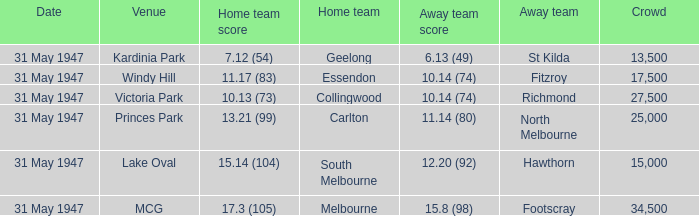What day is south melbourne at home? 31 May 1947. 